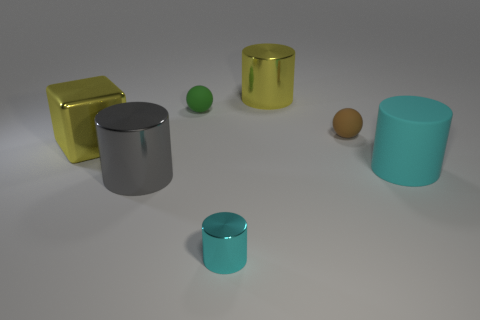Is the number of large cyan rubber cylinders to the left of the small green sphere greater than the number of gray metallic objects behind the gray metal cylinder?
Your response must be concise. No. Do the large cyan thing and the large yellow thing that is to the left of the tiny cyan metal object have the same material?
Your answer should be very brief. No. How many brown matte spheres are to the left of the big metallic cylinder behind the big shiny cylinder that is in front of the big matte cylinder?
Keep it short and to the point. 0. Is the shape of the gray metallic thing the same as the metal object that is in front of the gray metal object?
Offer a terse response. Yes. There is a shiny thing that is in front of the small green sphere and to the right of the green matte thing; what is its color?
Keep it short and to the point. Cyan. What material is the large yellow thing that is behind the large yellow shiny object that is to the left of the big metal thing that is in front of the rubber cylinder made of?
Make the answer very short. Metal. What is the big yellow cylinder made of?
Your answer should be very brief. Metal. There is another matte thing that is the same shape as the green object; what size is it?
Ensure brevity in your answer.  Small. Is the color of the small cylinder the same as the big matte cylinder?
Give a very brief answer. Yes. What number of other objects are there of the same material as the tiny brown thing?
Offer a terse response. 2. 